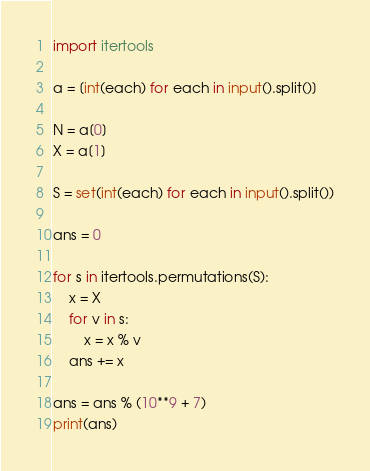<code> <loc_0><loc_0><loc_500><loc_500><_Python_>import itertools

a = [int(each) for each in input().split()]

N = a[0]
X = a[1]

S = set(int(each) for each in input().split())

ans = 0

for s in itertools.permutations(S):
    x = X
    for v in s:
        x = x % v
    ans += x

ans = ans % (10**9 + 7)
print(ans)
</code> 